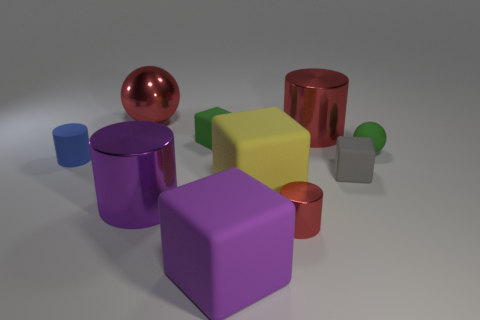Subtract all cubes. How many objects are left? 6 Add 7 tiny purple metallic balls. How many tiny purple metallic balls exist? 7 Subtract 2 red cylinders. How many objects are left? 8 Subtract all large brown spheres. Subtract all green matte blocks. How many objects are left? 9 Add 8 tiny green spheres. How many tiny green spheres are left? 9 